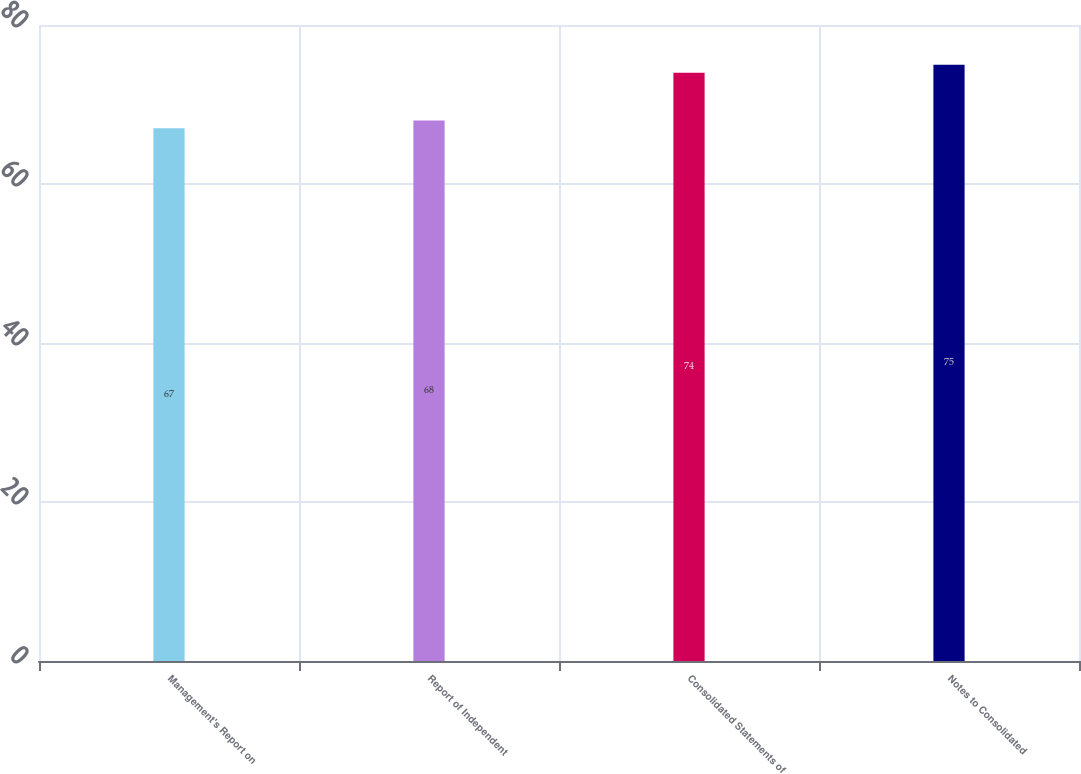Convert chart. <chart><loc_0><loc_0><loc_500><loc_500><bar_chart><fcel>Management's Report on<fcel>Report of Independent<fcel>Consolidated Statements of<fcel>Notes to Consolidated<nl><fcel>67<fcel>68<fcel>74<fcel>75<nl></chart> 